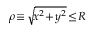Convert formula to latex. <formula><loc_0><loc_0><loc_500><loc_500>\rho \, \equiv \, \sqrt { \, x ^ { 2 } \, + \, y ^ { 2 } } \, \leq \, R</formula> 